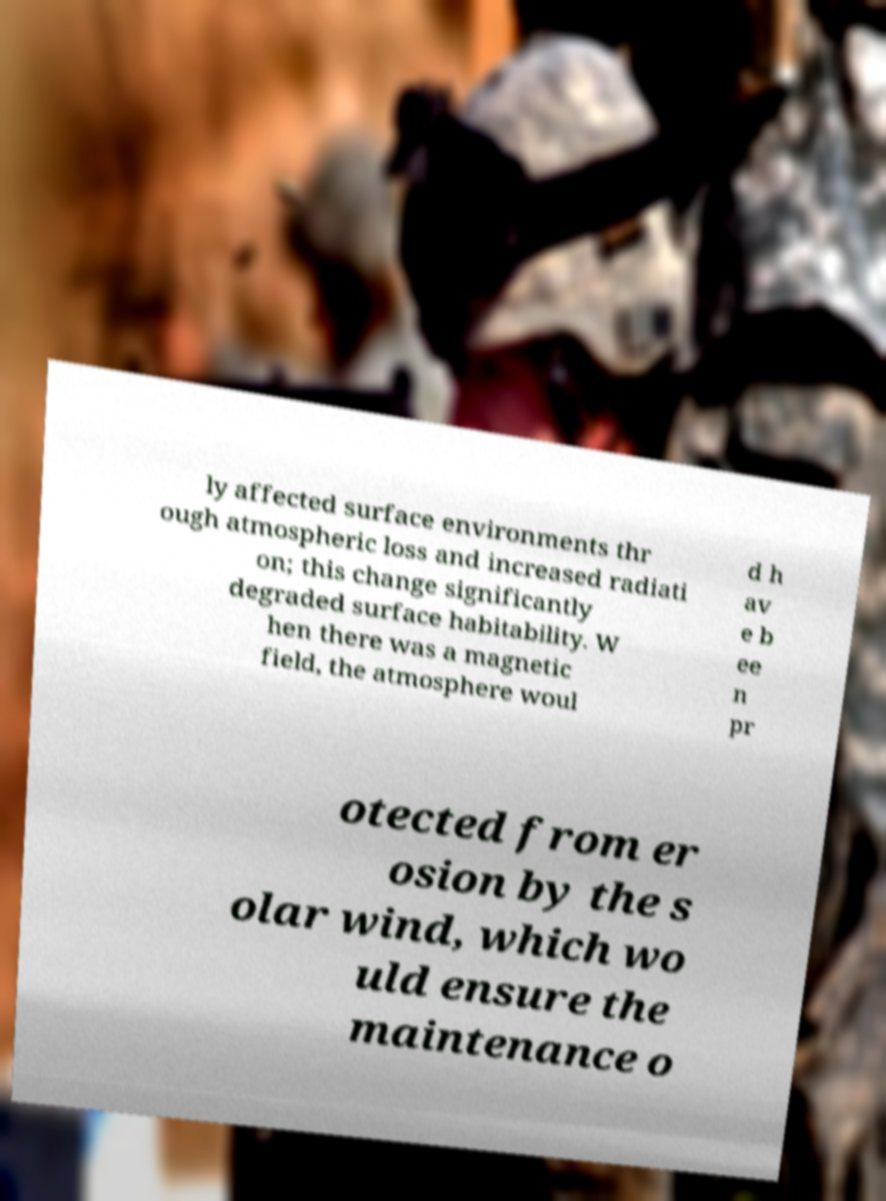Please read and relay the text visible in this image. What does it say? ly affected surface environments thr ough atmospheric loss and increased radiati on; this change significantly degraded surface habitability. W hen there was a magnetic field, the atmosphere woul d h av e b ee n pr otected from er osion by the s olar wind, which wo uld ensure the maintenance o 